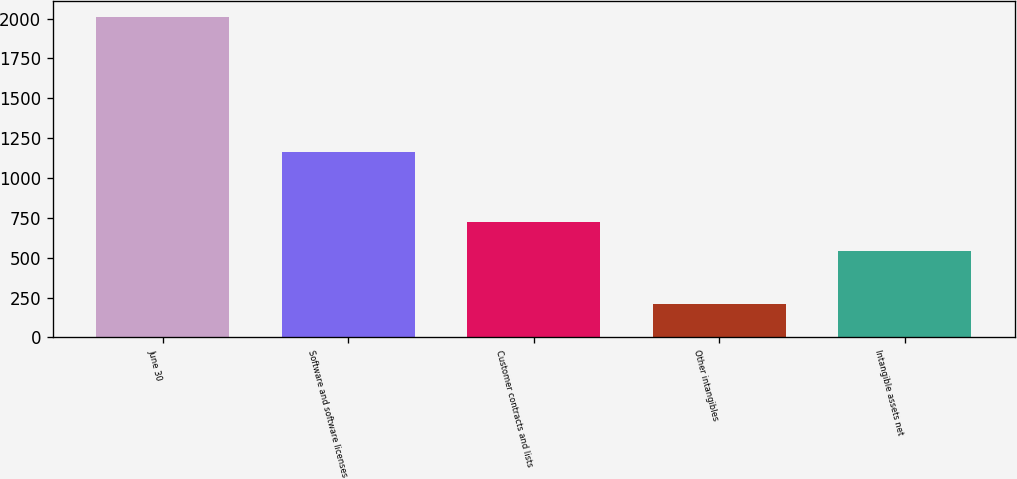Convert chart. <chart><loc_0><loc_0><loc_500><loc_500><bar_chart><fcel>June 30<fcel>Software and software licenses<fcel>Customer contracts and lists<fcel>Other intangibles<fcel>Intangible assets net<nl><fcel>2010<fcel>1160<fcel>722.45<fcel>209.5<fcel>542.4<nl></chart> 